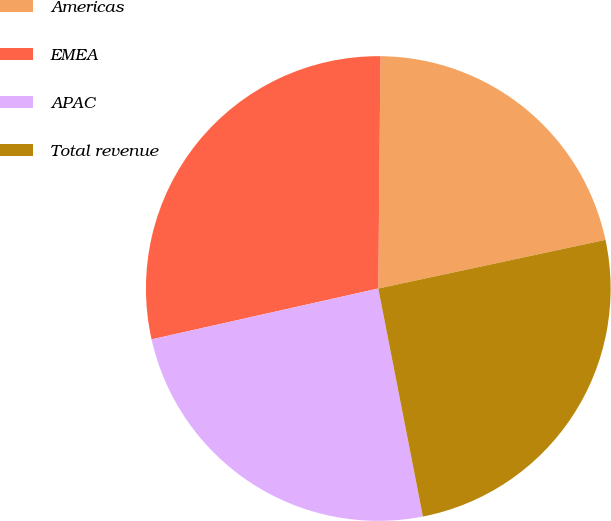Convert chart. <chart><loc_0><loc_0><loc_500><loc_500><pie_chart><fcel>Americas<fcel>EMEA<fcel>APAC<fcel>Total revenue<nl><fcel>21.49%<fcel>28.66%<fcel>24.56%<fcel>25.28%<nl></chart> 